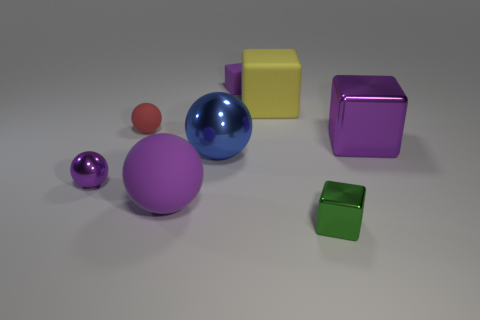How many purple blocks must be subtracted to get 1 purple blocks? 1 Subtract all large blue metallic balls. How many balls are left? 3 Add 1 red spheres. How many objects exist? 9 Subtract all red balls. How many balls are left? 3 Subtract 3 spheres. How many spheres are left? 1 Add 2 large cyan rubber things. How many large cyan rubber things exist? 2 Subtract 1 yellow blocks. How many objects are left? 7 Subtract all green cubes. Subtract all cyan cylinders. How many cubes are left? 3 Subtract all yellow cylinders. How many blue spheres are left? 1 Subtract all cyan things. Subtract all purple shiny blocks. How many objects are left? 7 